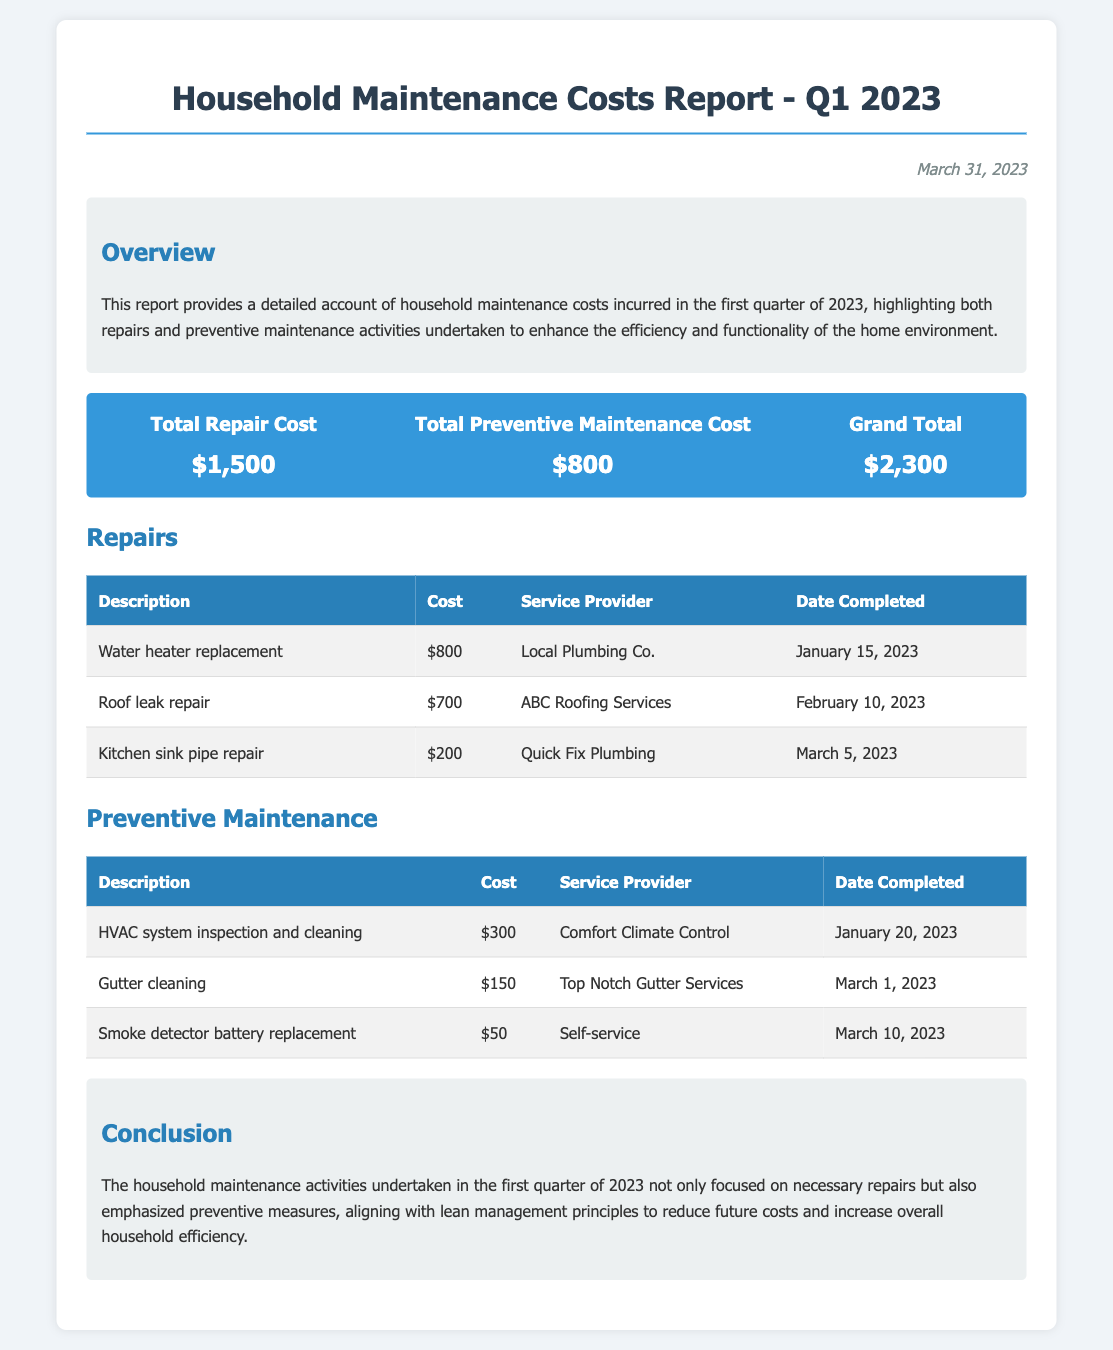What is the total repair cost? The total repair cost is listed in the cost summary section of the document as $1,500.
Answer: $1,500 What service provider handled the roof leak repair? The roof leak repair was carried out by the service provider named ABC Roofing Services.
Answer: ABC Roofing Services How much did the HVAC system inspection and cleaning cost? The cost for the HVAC system inspection and cleaning is specified in the preventive maintenance table as $300.
Answer: $300 What date was the smoke detector battery replacement completed? The completion date for the smoke detector battery replacement is noted as March 10, 2023.
Answer: March 10, 2023 What is the grand total for household maintenance costs in Q1 2023? The grand total for household maintenance costs is displayed in the cost summary as $2,300.
Answer: $2,300 How many repairs were listed in the report? There are three repairs detailed in the repairs section of the document.
Answer: Three What type of maintenance activities are emphasized in the conclusion? The conclusion emphasizes both necessary repairs and preventive maintenance activities undertaken.
Answer: Preventive maintenance Who completed the gutter cleaning service? The gutter cleaning service was performed by Top Notch Gutter Services as mentioned in the preventive maintenance table.
Answer: Top Notch Gutter Services What is the total cost of preventive maintenance activities? The total cost of preventive maintenance activities is provided in the cost summary as $800.
Answer: $800 